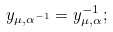<formula> <loc_0><loc_0><loc_500><loc_500>y _ { \mu , \alpha ^ { - 1 } } = y ^ { - 1 } _ { \mu , \alpha } ;</formula> 